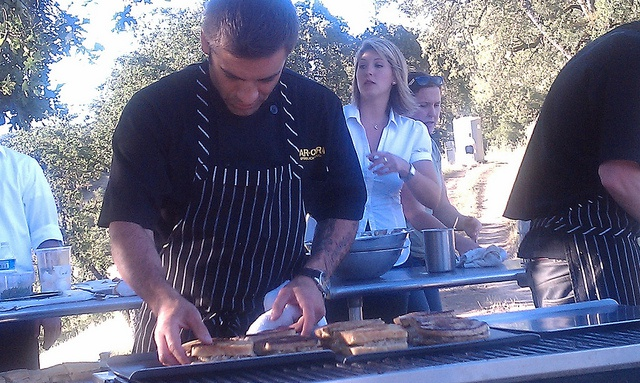Describe the objects in this image and their specific colors. I can see people in blue, black, navy, purple, and gray tones, people in blue, black, navy, purple, and gray tones, oven in blue, navy, and darkgray tones, people in blue, gray, and lightblue tones, and people in blue, lightblue, black, and gray tones in this image. 